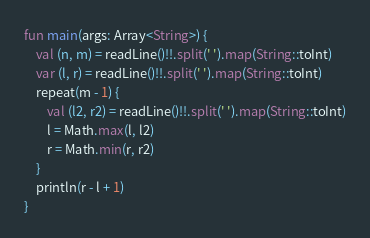<code> <loc_0><loc_0><loc_500><loc_500><_Kotlin_>fun main(args: Array<String>) {
    val (n, m) = readLine()!!.split(' ').map(String::toInt)
    var (l, r) = readLine()!!.split(' ').map(String::toInt)
    repeat(m - 1) {
        val (l2, r2) = readLine()!!.split(' ').map(String::toInt)
        l = Math.max(l, l2)
        r = Math.min(r, r2)
    }
    println(r - l + 1)
}
</code> 